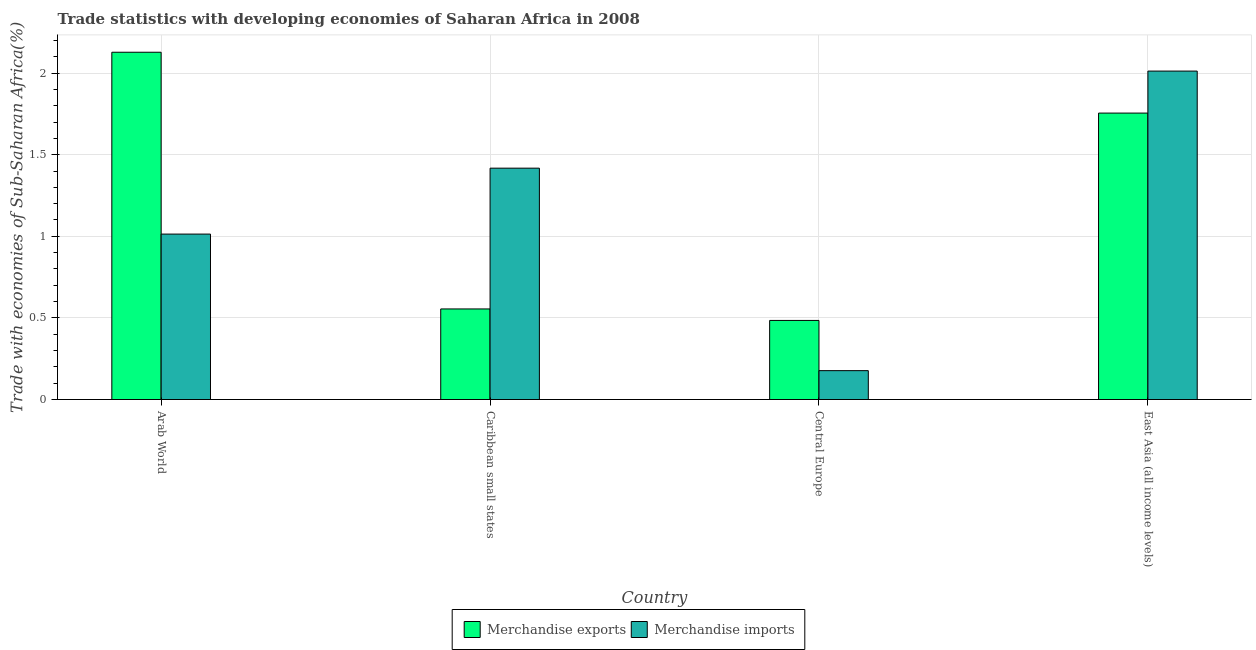How many different coloured bars are there?
Your response must be concise. 2. How many groups of bars are there?
Keep it short and to the point. 4. Are the number of bars on each tick of the X-axis equal?
Keep it short and to the point. Yes. How many bars are there on the 2nd tick from the left?
Your response must be concise. 2. How many bars are there on the 1st tick from the right?
Your answer should be compact. 2. What is the label of the 2nd group of bars from the left?
Give a very brief answer. Caribbean small states. In how many cases, is the number of bars for a given country not equal to the number of legend labels?
Keep it short and to the point. 0. What is the merchandise imports in Caribbean small states?
Your answer should be very brief. 1.42. Across all countries, what is the maximum merchandise exports?
Your answer should be very brief. 2.13. Across all countries, what is the minimum merchandise exports?
Your answer should be compact. 0.48. In which country was the merchandise imports maximum?
Provide a short and direct response. East Asia (all income levels). In which country was the merchandise imports minimum?
Offer a very short reply. Central Europe. What is the total merchandise imports in the graph?
Make the answer very short. 4.62. What is the difference between the merchandise imports in Arab World and that in Caribbean small states?
Give a very brief answer. -0.4. What is the difference between the merchandise exports in East Asia (all income levels) and the merchandise imports in Caribbean small states?
Keep it short and to the point. 0.34. What is the average merchandise exports per country?
Provide a short and direct response. 1.23. What is the difference between the merchandise exports and merchandise imports in Central Europe?
Offer a terse response. 0.31. In how many countries, is the merchandise exports greater than 1.7 %?
Your answer should be very brief. 2. What is the ratio of the merchandise imports in Central Europe to that in East Asia (all income levels)?
Give a very brief answer. 0.09. What is the difference between the highest and the second highest merchandise imports?
Provide a short and direct response. 0.59. What is the difference between the highest and the lowest merchandise imports?
Your answer should be very brief. 1.84. In how many countries, is the merchandise imports greater than the average merchandise imports taken over all countries?
Offer a very short reply. 2. What does the 1st bar from the left in East Asia (all income levels) represents?
Offer a terse response. Merchandise exports. What does the 2nd bar from the right in Arab World represents?
Keep it short and to the point. Merchandise exports. Are all the bars in the graph horizontal?
Keep it short and to the point. No. How many countries are there in the graph?
Offer a very short reply. 4. What is the difference between two consecutive major ticks on the Y-axis?
Offer a very short reply. 0.5. Are the values on the major ticks of Y-axis written in scientific E-notation?
Ensure brevity in your answer.  No. Does the graph contain grids?
Provide a succinct answer. Yes. How many legend labels are there?
Make the answer very short. 2. What is the title of the graph?
Your answer should be compact. Trade statistics with developing economies of Saharan Africa in 2008. Does "Net National savings" appear as one of the legend labels in the graph?
Offer a very short reply. No. What is the label or title of the X-axis?
Offer a terse response. Country. What is the label or title of the Y-axis?
Ensure brevity in your answer.  Trade with economies of Sub-Saharan Africa(%). What is the Trade with economies of Sub-Saharan Africa(%) of Merchandise exports in Arab World?
Your answer should be compact. 2.13. What is the Trade with economies of Sub-Saharan Africa(%) in Merchandise imports in Arab World?
Ensure brevity in your answer.  1.01. What is the Trade with economies of Sub-Saharan Africa(%) in Merchandise exports in Caribbean small states?
Give a very brief answer. 0.55. What is the Trade with economies of Sub-Saharan Africa(%) in Merchandise imports in Caribbean small states?
Your answer should be very brief. 1.42. What is the Trade with economies of Sub-Saharan Africa(%) of Merchandise exports in Central Europe?
Give a very brief answer. 0.48. What is the Trade with economies of Sub-Saharan Africa(%) of Merchandise imports in Central Europe?
Make the answer very short. 0.18. What is the Trade with economies of Sub-Saharan Africa(%) in Merchandise exports in East Asia (all income levels)?
Give a very brief answer. 1.75. What is the Trade with economies of Sub-Saharan Africa(%) in Merchandise imports in East Asia (all income levels)?
Offer a very short reply. 2.01. Across all countries, what is the maximum Trade with economies of Sub-Saharan Africa(%) in Merchandise exports?
Your answer should be compact. 2.13. Across all countries, what is the maximum Trade with economies of Sub-Saharan Africa(%) in Merchandise imports?
Give a very brief answer. 2.01. Across all countries, what is the minimum Trade with economies of Sub-Saharan Africa(%) in Merchandise exports?
Your answer should be very brief. 0.48. Across all countries, what is the minimum Trade with economies of Sub-Saharan Africa(%) in Merchandise imports?
Keep it short and to the point. 0.18. What is the total Trade with economies of Sub-Saharan Africa(%) of Merchandise exports in the graph?
Provide a succinct answer. 4.92. What is the total Trade with economies of Sub-Saharan Africa(%) of Merchandise imports in the graph?
Your response must be concise. 4.62. What is the difference between the Trade with economies of Sub-Saharan Africa(%) of Merchandise exports in Arab World and that in Caribbean small states?
Your response must be concise. 1.57. What is the difference between the Trade with economies of Sub-Saharan Africa(%) in Merchandise imports in Arab World and that in Caribbean small states?
Ensure brevity in your answer.  -0.4. What is the difference between the Trade with economies of Sub-Saharan Africa(%) of Merchandise exports in Arab World and that in Central Europe?
Make the answer very short. 1.64. What is the difference between the Trade with economies of Sub-Saharan Africa(%) in Merchandise imports in Arab World and that in Central Europe?
Your answer should be very brief. 0.84. What is the difference between the Trade with economies of Sub-Saharan Africa(%) in Merchandise exports in Arab World and that in East Asia (all income levels)?
Your answer should be very brief. 0.37. What is the difference between the Trade with economies of Sub-Saharan Africa(%) in Merchandise imports in Arab World and that in East Asia (all income levels)?
Give a very brief answer. -1. What is the difference between the Trade with economies of Sub-Saharan Africa(%) in Merchandise exports in Caribbean small states and that in Central Europe?
Give a very brief answer. 0.07. What is the difference between the Trade with economies of Sub-Saharan Africa(%) of Merchandise imports in Caribbean small states and that in Central Europe?
Give a very brief answer. 1.24. What is the difference between the Trade with economies of Sub-Saharan Africa(%) in Merchandise exports in Caribbean small states and that in East Asia (all income levels)?
Offer a very short reply. -1.2. What is the difference between the Trade with economies of Sub-Saharan Africa(%) of Merchandise imports in Caribbean small states and that in East Asia (all income levels)?
Offer a very short reply. -0.59. What is the difference between the Trade with economies of Sub-Saharan Africa(%) of Merchandise exports in Central Europe and that in East Asia (all income levels)?
Provide a short and direct response. -1.27. What is the difference between the Trade with economies of Sub-Saharan Africa(%) in Merchandise imports in Central Europe and that in East Asia (all income levels)?
Your answer should be very brief. -1.84. What is the difference between the Trade with economies of Sub-Saharan Africa(%) of Merchandise exports in Arab World and the Trade with economies of Sub-Saharan Africa(%) of Merchandise imports in Caribbean small states?
Your answer should be very brief. 0.71. What is the difference between the Trade with economies of Sub-Saharan Africa(%) in Merchandise exports in Arab World and the Trade with economies of Sub-Saharan Africa(%) in Merchandise imports in Central Europe?
Make the answer very short. 1.95. What is the difference between the Trade with economies of Sub-Saharan Africa(%) in Merchandise exports in Arab World and the Trade with economies of Sub-Saharan Africa(%) in Merchandise imports in East Asia (all income levels)?
Your answer should be very brief. 0.12. What is the difference between the Trade with economies of Sub-Saharan Africa(%) of Merchandise exports in Caribbean small states and the Trade with economies of Sub-Saharan Africa(%) of Merchandise imports in Central Europe?
Your answer should be compact. 0.38. What is the difference between the Trade with economies of Sub-Saharan Africa(%) of Merchandise exports in Caribbean small states and the Trade with economies of Sub-Saharan Africa(%) of Merchandise imports in East Asia (all income levels)?
Give a very brief answer. -1.46. What is the difference between the Trade with economies of Sub-Saharan Africa(%) of Merchandise exports in Central Europe and the Trade with economies of Sub-Saharan Africa(%) of Merchandise imports in East Asia (all income levels)?
Make the answer very short. -1.53. What is the average Trade with economies of Sub-Saharan Africa(%) in Merchandise exports per country?
Give a very brief answer. 1.23. What is the average Trade with economies of Sub-Saharan Africa(%) in Merchandise imports per country?
Provide a short and direct response. 1.16. What is the difference between the Trade with economies of Sub-Saharan Africa(%) in Merchandise exports and Trade with economies of Sub-Saharan Africa(%) in Merchandise imports in Arab World?
Provide a short and direct response. 1.11. What is the difference between the Trade with economies of Sub-Saharan Africa(%) of Merchandise exports and Trade with economies of Sub-Saharan Africa(%) of Merchandise imports in Caribbean small states?
Ensure brevity in your answer.  -0.86. What is the difference between the Trade with economies of Sub-Saharan Africa(%) in Merchandise exports and Trade with economies of Sub-Saharan Africa(%) in Merchandise imports in Central Europe?
Your response must be concise. 0.31. What is the difference between the Trade with economies of Sub-Saharan Africa(%) in Merchandise exports and Trade with economies of Sub-Saharan Africa(%) in Merchandise imports in East Asia (all income levels)?
Ensure brevity in your answer.  -0.26. What is the ratio of the Trade with economies of Sub-Saharan Africa(%) in Merchandise exports in Arab World to that in Caribbean small states?
Offer a very short reply. 3.83. What is the ratio of the Trade with economies of Sub-Saharan Africa(%) in Merchandise imports in Arab World to that in Caribbean small states?
Give a very brief answer. 0.72. What is the ratio of the Trade with economies of Sub-Saharan Africa(%) in Merchandise exports in Arab World to that in Central Europe?
Keep it short and to the point. 4.39. What is the ratio of the Trade with economies of Sub-Saharan Africa(%) in Merchandise imports in Arab World to that in Central Europe?
Give a very brief answer. 5.73. What is the ratio of the Trade with economies of Sub-Saharan Africa(%) of Merchandise exports in Arab World to that in East Asia (all income levels)?
Make the answer very short. 1.21. What is the ratio of the Trade with economies of Sub-Saharan Africa(%) in Merchandise imports in Arab World to that in East Asia (all income levels)?
Make the answer very short. 0.5. What is the ratio of the Trade with economies of Sub-Saharan Africa(%) of Merchandise exports in Caribbean small states to that in Central Europe?
Offer a terse response. 1.15. What is the ratio of the Trade with economies of Sub-Saharan Africa(%) in Merchandise imports in Caribbean small states to that in Central Europe?
Provide a short and direct response. 8.01. What is the ratio of the Trade with economies of Sub-Saharan Africa(%) of Merchandise exports in Caribbean small states to that in East Asia (all income levels)?
Your answer should be compact. 0.32. What is the ratio of the Trade with economies of Sub-Saharan Africa(%) in Merchandise imports in Caribbean small states to that in East Asia (all income levels)?
Your response must be concise. 0.7. What is the ratio of the Trade with economies of Sub-Saharan Africa(%) of Merchandise exports in Central Europe to that in East Asia (all income levels)?
Offer a very short reply. 0.28. What is the ratio of the Trade with economies of Sub-Saharan Africa(%) in Merchandise imports in Central Europe to that in East Asia (all income levels)?
Keep it short and to the point. 0.09. What is the difference between the highest and the second highest Trade with economies of Sub-Saharan Africa(%) of Merchandise exports?
Your response must be concise. 0.37. What is the difference between the highest and the second highest Trade with economies of Sub-Saharan Africa(%) of Merchandise imports?
Keep it short and to the point. 0.59. What is the difference between the highest and the lowest Trade with economies of Sub-Saharan Africa(%) in Merchandise exports?
Provide a succinct answer. 1.64. What is the difference between the highest and the lowest Trade with economies of Sub-Saharan Africa(%) of Merchandise imports?
Make the answer very short. 1.84. 